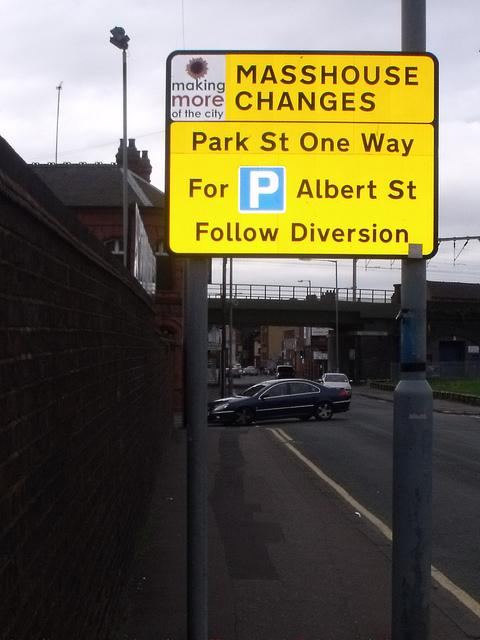Why is the yellow sign posted outdoors? directions 